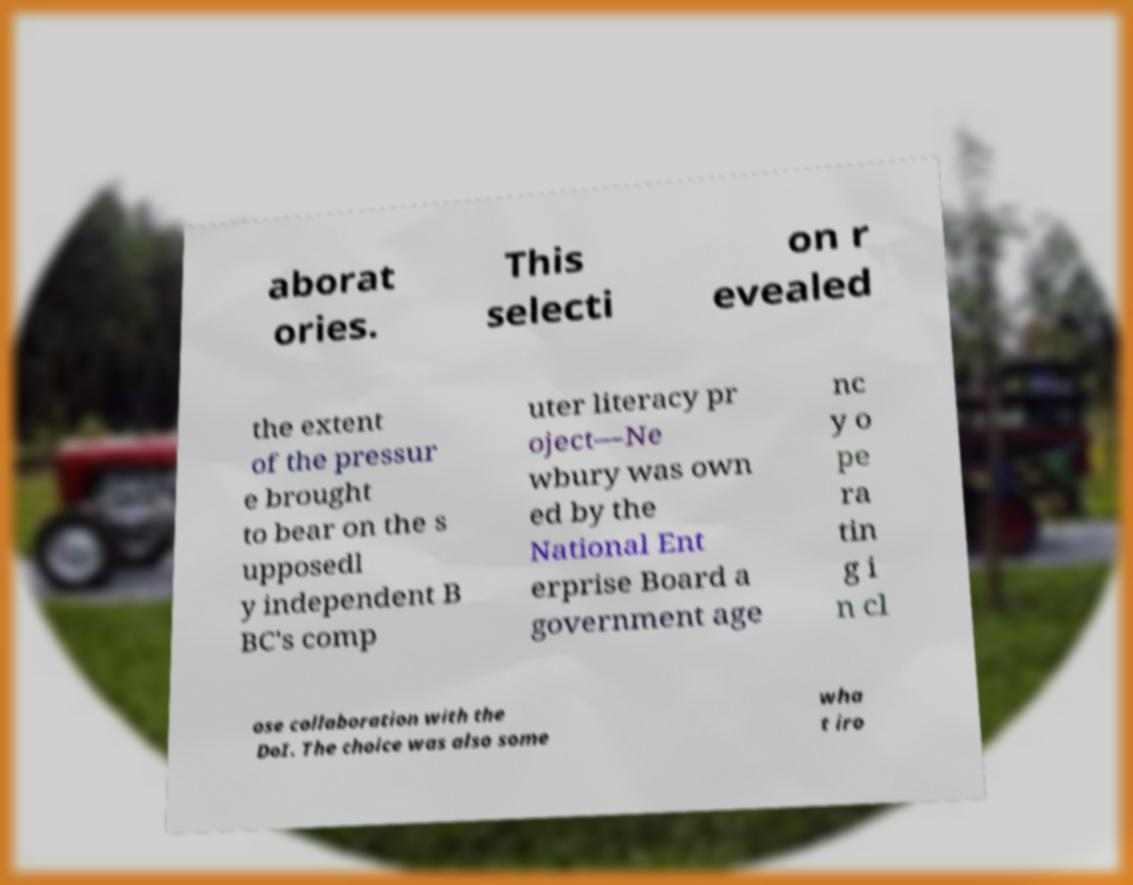I need the written content from this picture converted into text. Can you do that? aborat ories. This selecti on r evealed the extent of the pressur e brought to bear on the s upposedl y independent B BC's comp uter literacy pr oject—Ne wbury was own ed by the National Ent erprise Board a government age nc y o pe ra tin g i n cl ose collaboration with the DoI. The choice was also some wha t iro 